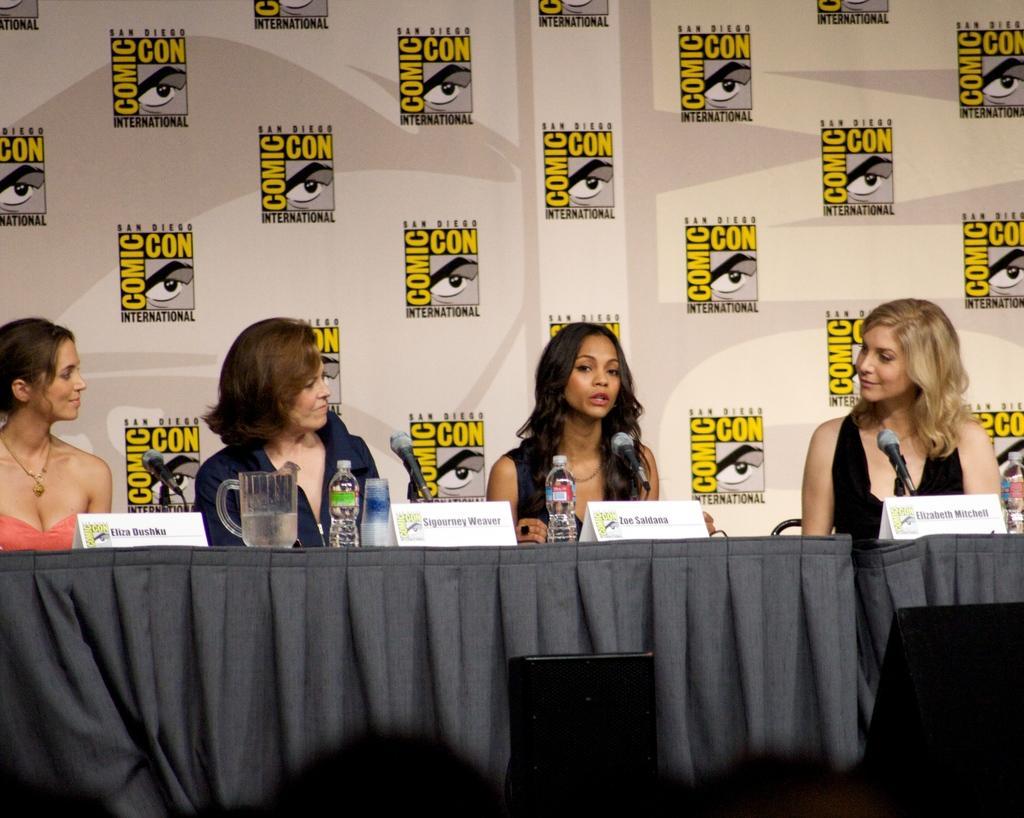In one or two sentences, can you explain what this image depicts? This picture is clicked in the conference hall. In this picture, we see four women sitting on the chairs. The woman in the black dress is talking on the microphone. In front of them, we see a table which is covered with black color cloth. On the table, we see water bottle, jar, glass, name boards and microphone. Behind them, we see a white color banner. 